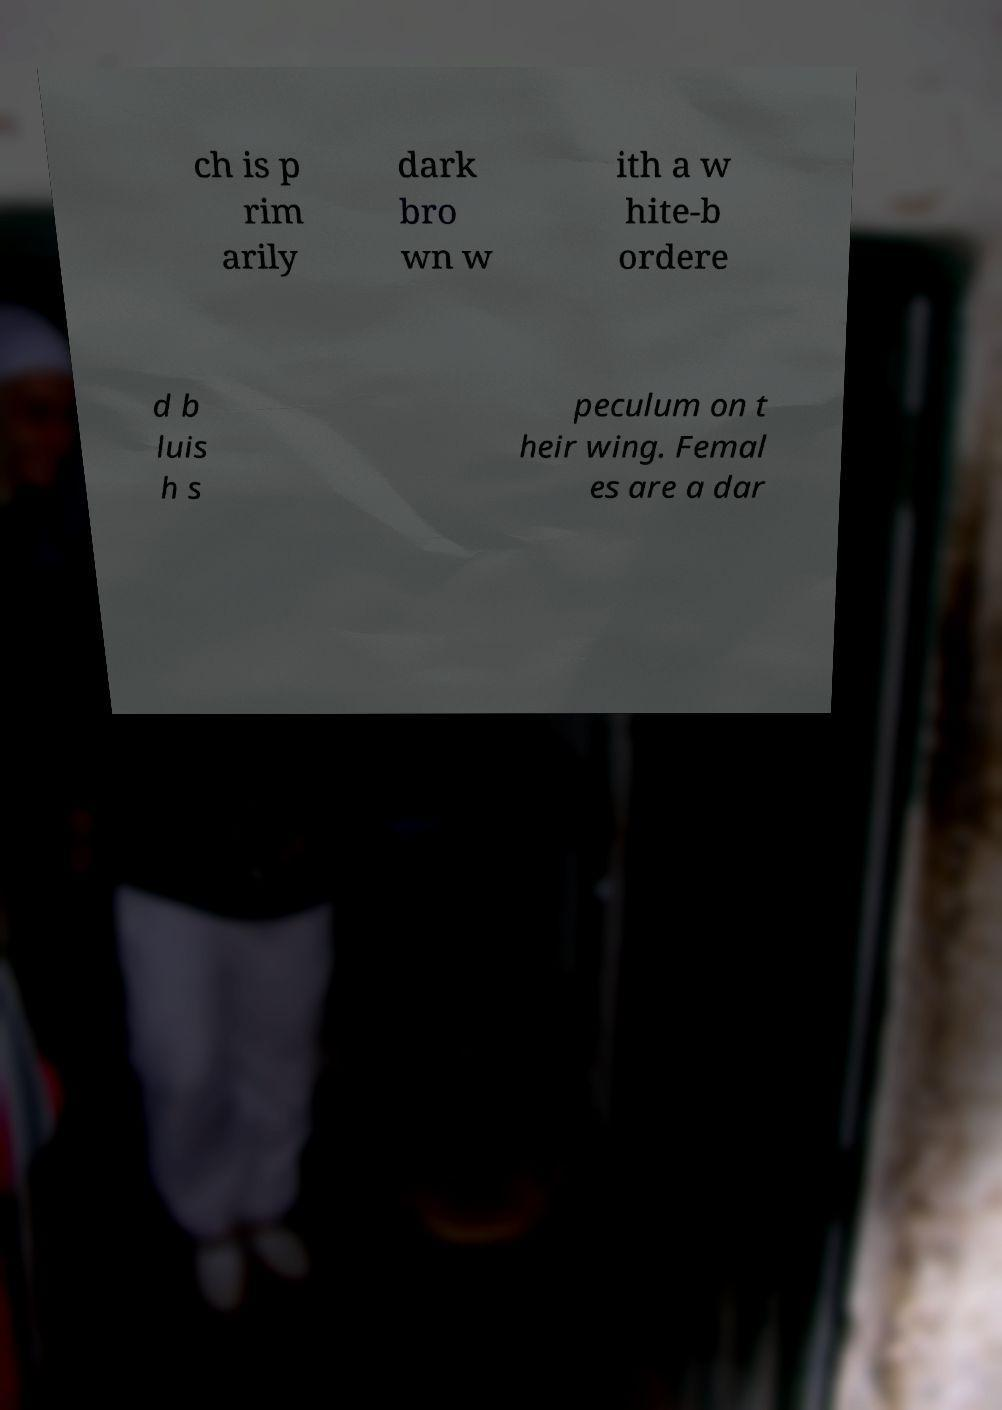Can you accurately transcribe the text from the provided image for me? ch is p rim arily dark bro wn w ith a w hite-b ordere d b luis h s peculum on t heir wing. Femal es are a dar 